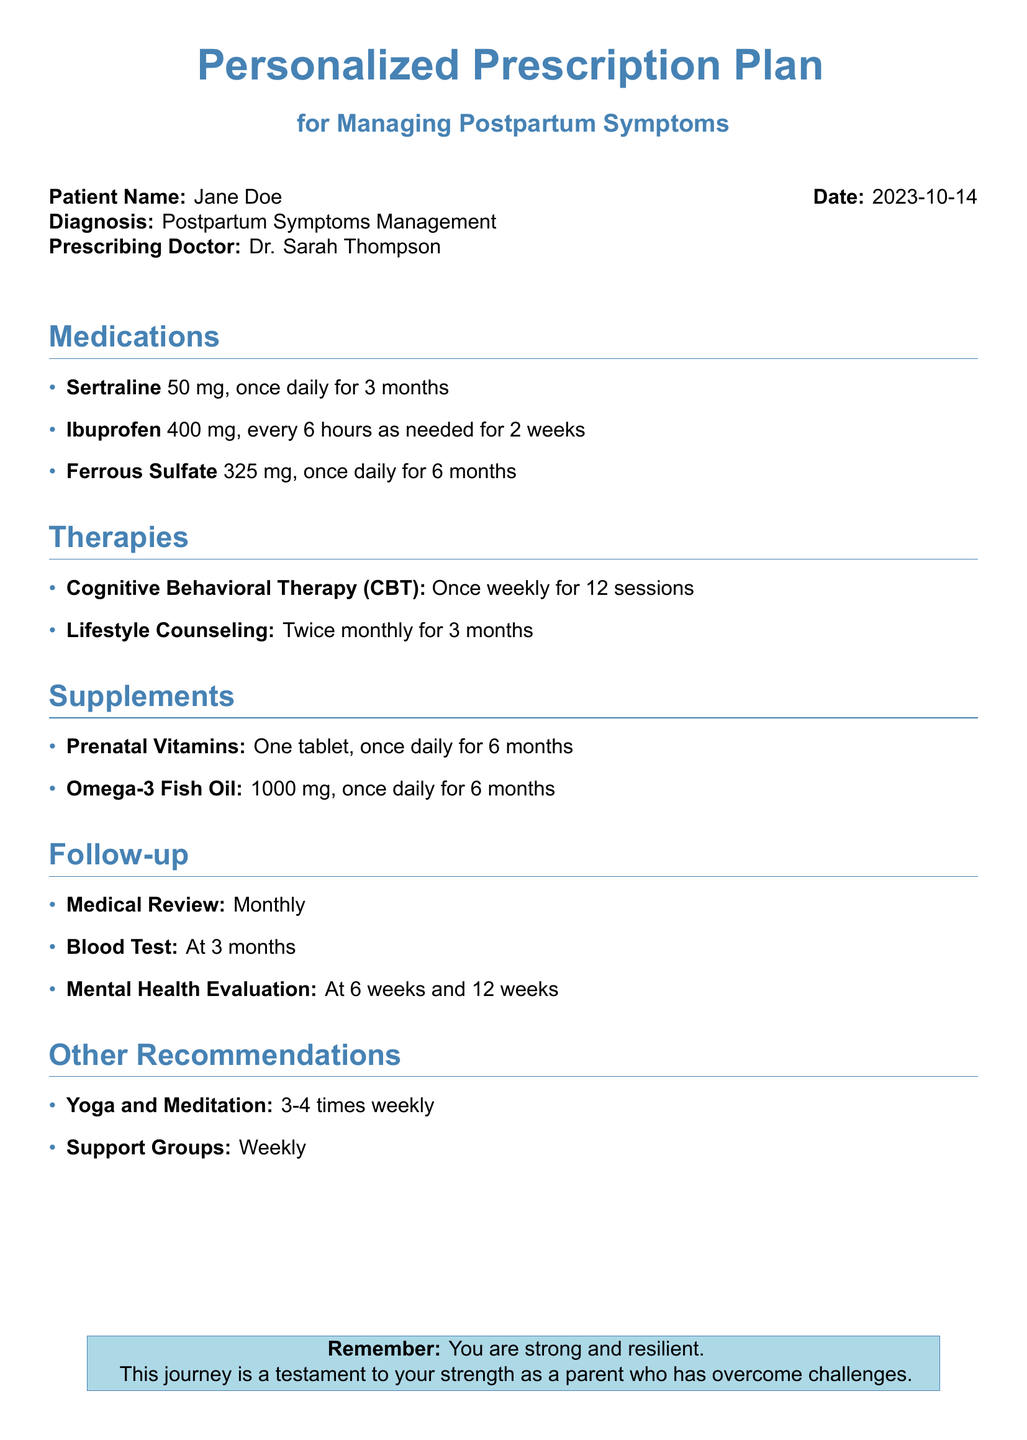What is the patient's name? The patient's name is mentioned at the beginning of the document in a specific format: "Patient Name: Jane Doe."
Answer: Jane Doe What is the diagnosis listed? The diagnosis is explicitly stated in the document as "Diagnosis: Postpartum Symptoms Management."
Answer: Postpartum Symptoms Management How long is Sertraline prescribed for? The duration of Sertraline prescription is provided as "once daily for 3 months."
Answer: 3 months How often should Cognitive Behavioral Therapy be conducted? The document states that CBT sessions are "Once weekly for 12 sessions."
Answer: Once weekly What is the dosage of Ibuprofen listed? The dosage of Ibuprofen prescribed is specified as "400 mg, every 6 hours as needed for 2 weeks."
Answer: 400 mg How many follow-up medical reviews are scheduled? The document states "Monthly" for medical reviews without specifying a quantity.
Answer: Monthly What type of therapy is recommended in addition to medications? The document includes "Cognitive Behavioral Therapy (CBT)" as a type of therapy recommended.
Answer: Cognitive Behavioral Therapy (CBT) When is the mental health evaluation scheduled? The evaluations are planned for "At 6 weeks and 12 weeks" after the initial appointment.
Answer: At 6 weeks and 12 weeks 